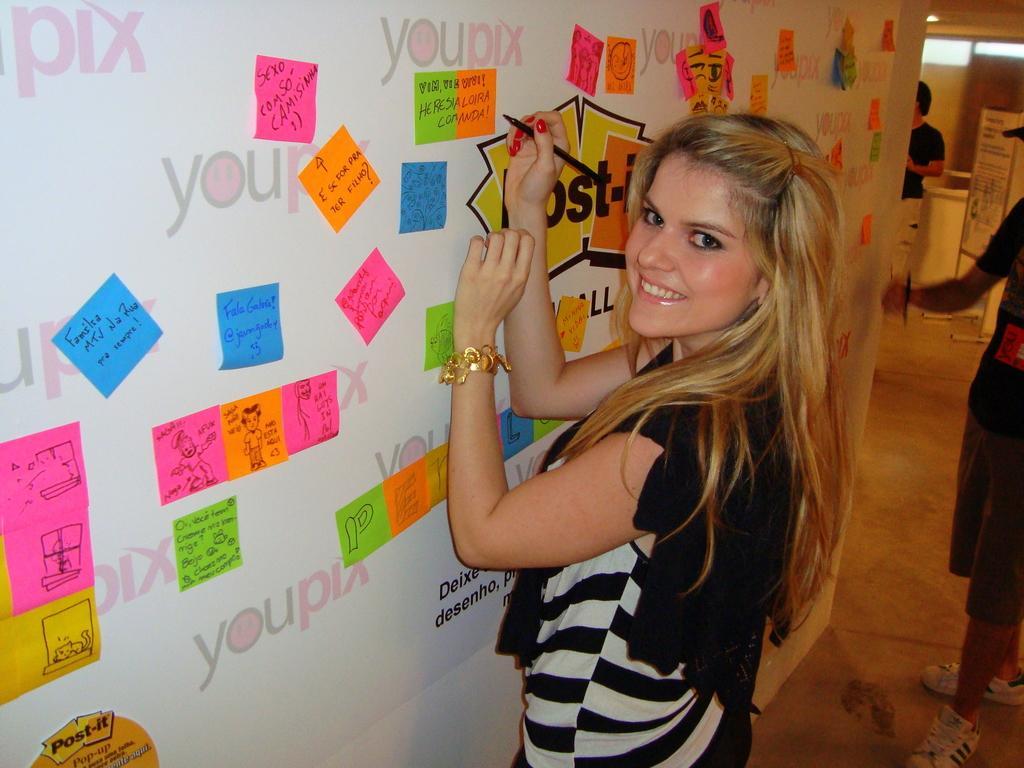Can you describe this image briefly? In this image we can see a lady holding a pen. There is a wall with different colored papers past. On the papers we can see text and drawings. On the right side we can see two other persons. Also there is a board with stand. 